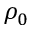Convert formula to latex. <formula><loc_0><loc_0><loc_500><loc_500>\rho _ { 0 }</formula> 